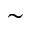<formula> <loc_0><loc_0><loc_500><loc_500>\sim</formula> 